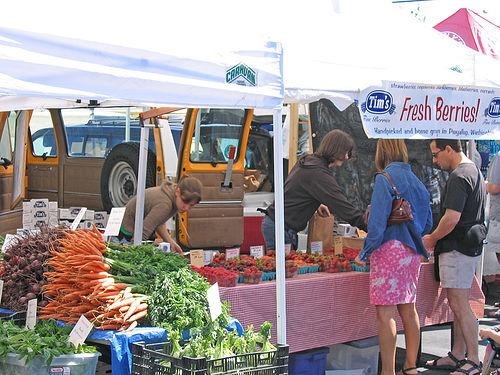Question: what are the colors of the woman's skirt?
Choices:
A. Black and white.
B. Grey and yellow.
C. Red, white, and blue.
D. White and pink.
Answer with the letter. Answer: D Question: who is at the stand?
Choices:
A. People.
B. A monkey.
C. A hot dog vendor and his seeing eye dog.
D. A girl on a horse.
Answer with the letter. Answer: A Question: why are the people at the stand?
Choices:
A. To buy hot dogs.
B. Looking at fresh berries.
C. To get a drink.
D. Looking at paintings.
Answer with the letter. Answer: B 